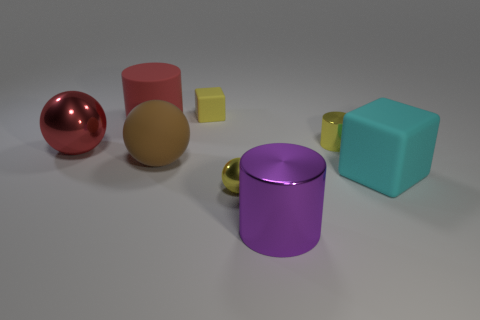Subtract all red cylinders. How many cylinders are left? 2 Add 1 big purple cylinders. How many objects exist? 9 Subtract all purple cylinders. How many cylinders are left? 2 Subtract 3 balls. How many balls are left? 0 Add 1 red cylinders. How many red cylinders are left? 2 Add 1 yellow shiny spheres. How many yellow shiny spheres exist? 2 Subtract 0 green cylinders. How many objects are left? 8 Subtract all balls. How many objects are left? 5 Subtract all yellow spheres. Subtract all blue cylinders. How many spheres are left? 2 Subtract all yellow rubber cubes. Subtract all large cylinders. How many objects are left? 5 